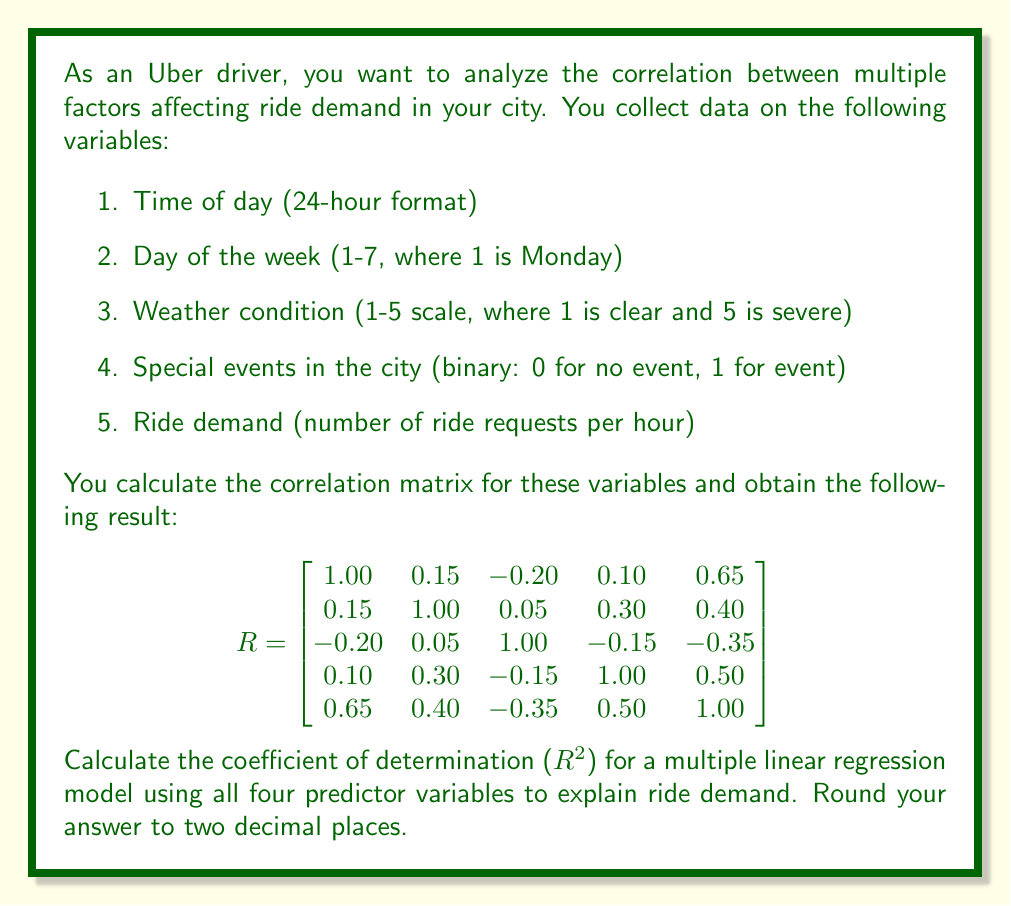Could you help me with this problem? To solve this problem, we need to understand the following concepts:

1. The correlation matrix (R) provides the Pearson correlation coefficients between all pairs of variables.
2. The coefficient of determination ($R^2$) in multiple linear regression represents the proportion of variance in the dependent variable that is predictable from the independent variables.
3. For multiple regression, $R^2$ can be calculated using the correlation coefficients between the dependent variable and the independent variables.

Step 1: Identify the correlations between ride demand (dependent variable) and the predictor variables.
From the last row (or column) of the correlation matrix:
- Correlation between time of day and ride demand: $r_{15} = 0.65$
- Correlation between day of the week and ride demand: $r_{25} = 0.40$
- Correlation between weather condition and ride demand: $r_{35} = -0.35$
- Correlation between special events and ride demand: $r_{45} = 0.50$

Step 2: Calculate $R^2$ using the formula for multiple regression:

$$R^2 = r_{y\hat{y}}^2 = \mathbf{r}_{y\mathbf{x}}^T \mathbf{R}_{\mathbf{xx}}^{-1} \mathbf{r}_{y\mathbf{x}}$$

Where:
- $\mathbf{r}_{y\mathbf{x}}$ is the vector of correlations between the dependent variable and each independent variable
- $\mathbf{R}_{\mathbf{xx}}$ is the correlation matrix of the independent variables

In this case:

$$\mathbf{r}_{y\mathbf{x}} = \begin{bmatrix} 0.65 \\ 0.40 \\ -0.35 \\ 0.50 \end{bmatrix}$$

$$\mathbf{R}_{\mathbf{xx}} = \begin{bmatrix}
1.00 & 0.15 & -0.20 & 0.10 \\
0.15 & 1.00 & 0.05 & 0.30 \\
-0.20 & 0.05 & 1.00 & -0.15 \\
0.10 & 0.30 & -0.15 & 1.00
\end{bmatrix}$$

Step 3: Calculate $\mathbf{R}_{\mathbf{xx}}^{-1}$ (inverse of the correlation matrix of independent variables).

Step 4: Perform the matrix multiplication $\mathbf{r}_{y\mathbf{x}}^T \mathbf{R}_{\mathbf{xx}}^{-1} \mathbf{r}_{y\mathbf{x}}$.

Step 5: The result of this multiplication is the $R^2$ value.

Using a calculator or computer software to perform these matrix operations, we get:

$$R^2 = 0.7234$$

Step 6: Round the result to two decimal places.

$$R^2 \approx 0.72$$
Answer: $R^2 = 0.72$ 